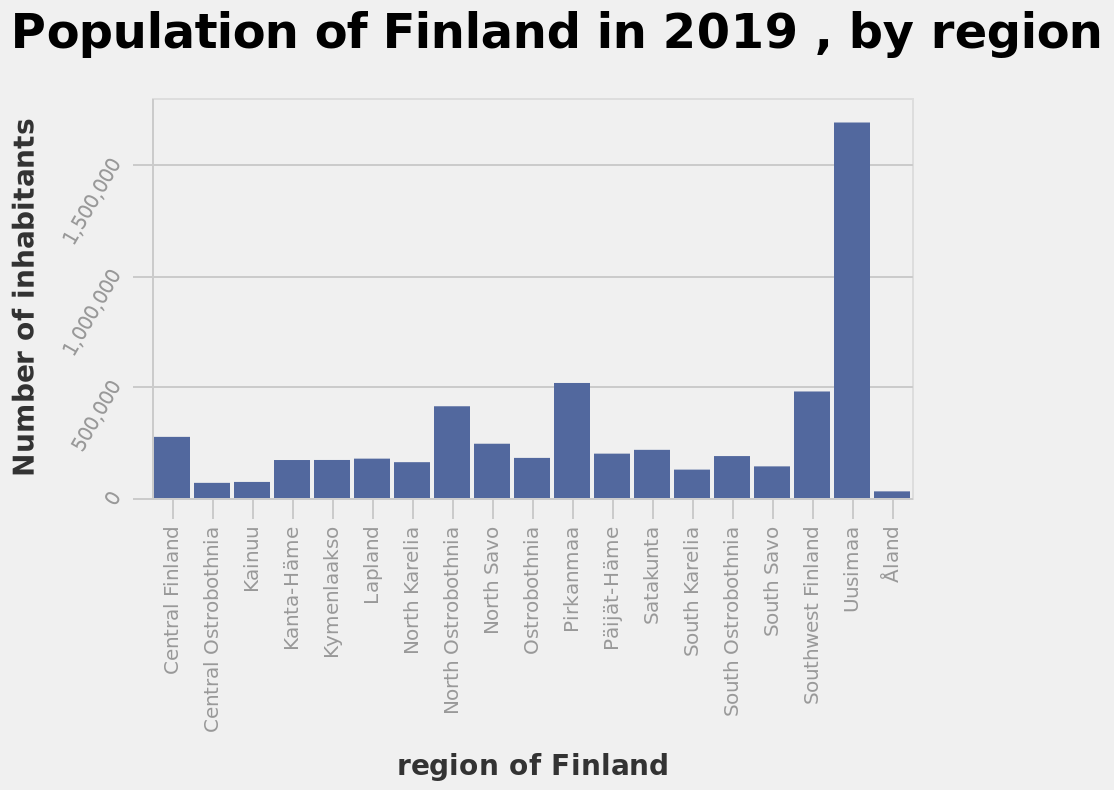<image>
please describe the details of the chart Population of Finland in 2019 , by region is a bar graph. The x-axis measures region of Finland while the y-axis plots Number of inhabitants. What does the bar graph represent? The bar graph represents the population of Finland in 2019, categorized by region. What is the population range for most regions in Finland? Most regions in Finland have a population between 100,000 and 500,000 inhabitants. What does the x-axis measure in the bar graph?  The x-axis measures the regions of Finland. Does the bar graph represent the population of Denmark in 2019, categorized by gender? No.The bar graph represents the population of Finland in 2019, categorized by region. 